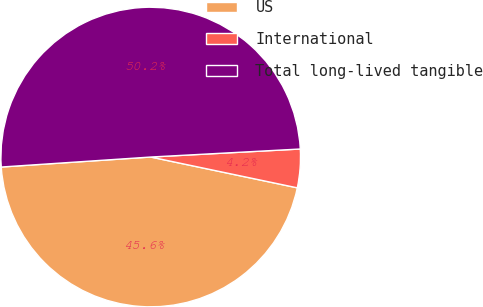Convert chart to OTSL. <chart><loc_0><loc_0><loc_500><loc_500><pie_chart><fcel>US<fcel>International<fcel>Total long-lived tangible<nl><fcel>45.64%<fcel>4.15%<fcel>50.21%<nl></chart> 